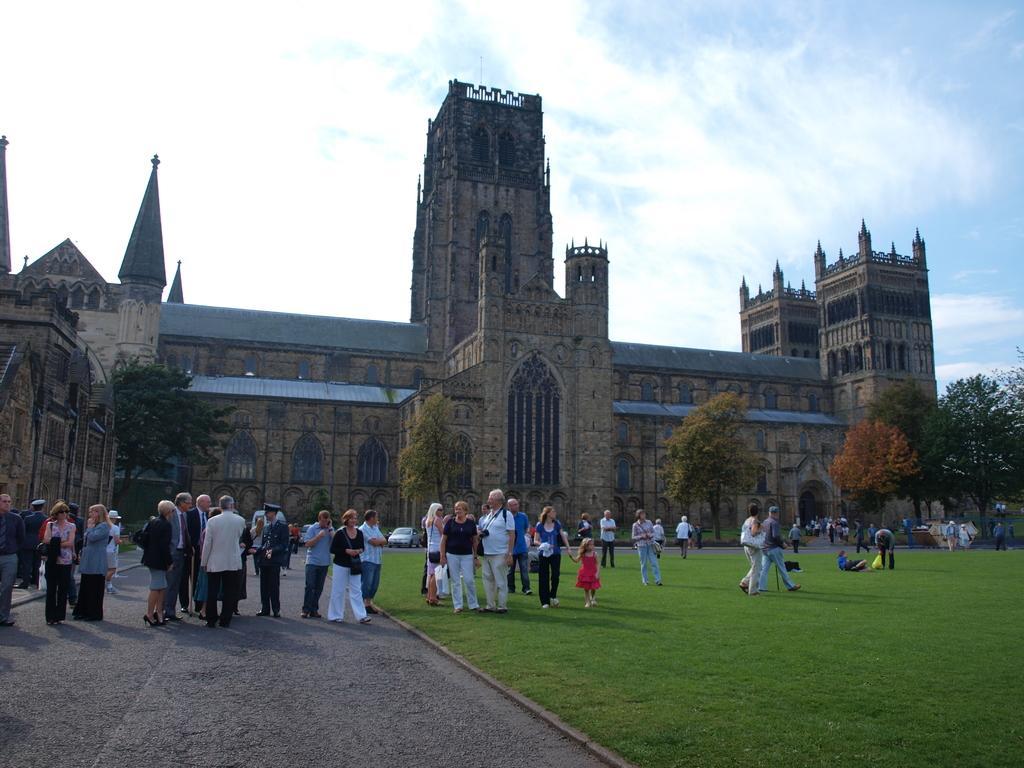In one or two sentences, can you explain what this image depicts? In this image in front there is a road. There are people standing. On the right side of the image there is grass on the surface. In the background of the image there are cars, trees, buildings. At the top of the image there is sky. 